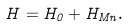Convert formula to latex. <formula><loc_0><loc_0><loc_500><loc_500>H = H _ { 0 } + H _ { M n } .</formula> 